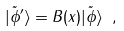<formula> <loc_0><loc_0><loc_500><loc_500>| \tilde { \phi } ^ { \prime } \rangle = B ( { x } ) | \tilde { \phi } \rangle \ ,</formula> 